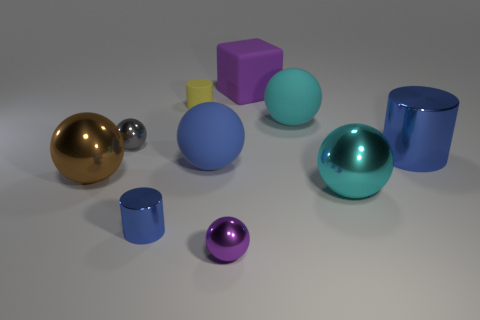Can you tell me which objects look similar in material and reflectivity? Certainly, the objects sharing similar material qualities and reflectiveness are the two spherical ones - one large and blue and the other, smaller and golden, along with two cylindrical cups with a blue hue. They all exhibit a polished, shiny finish indicating a metallic material. 